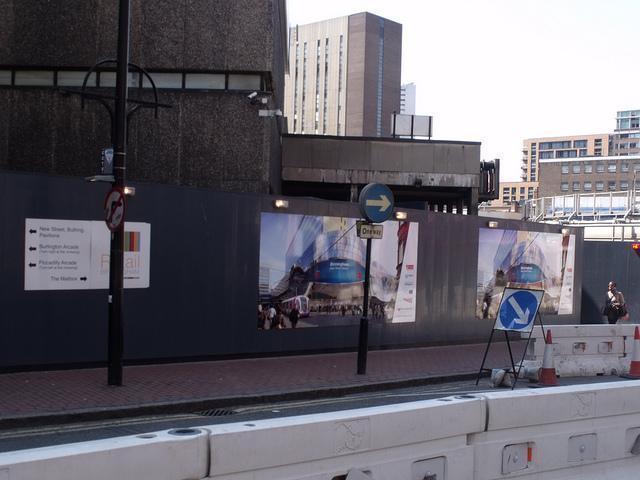What are the blue signs being used for?
Answer the question by selecting the correct answer among the 4 following choices.
Options: Decoration, advertising, selling, directing traffic. Directing traffic. 